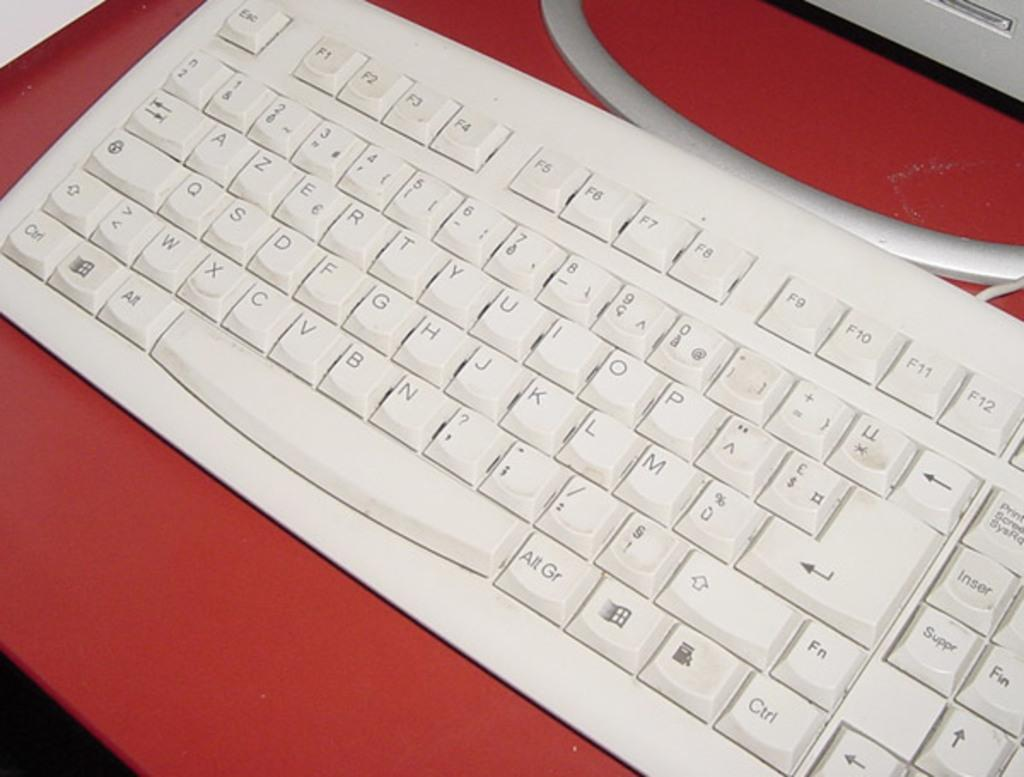<image>
Create a compact narrative representing the image presented. A white keyboard has an Alt key and an Alt Gr key on either side of the space bar. 